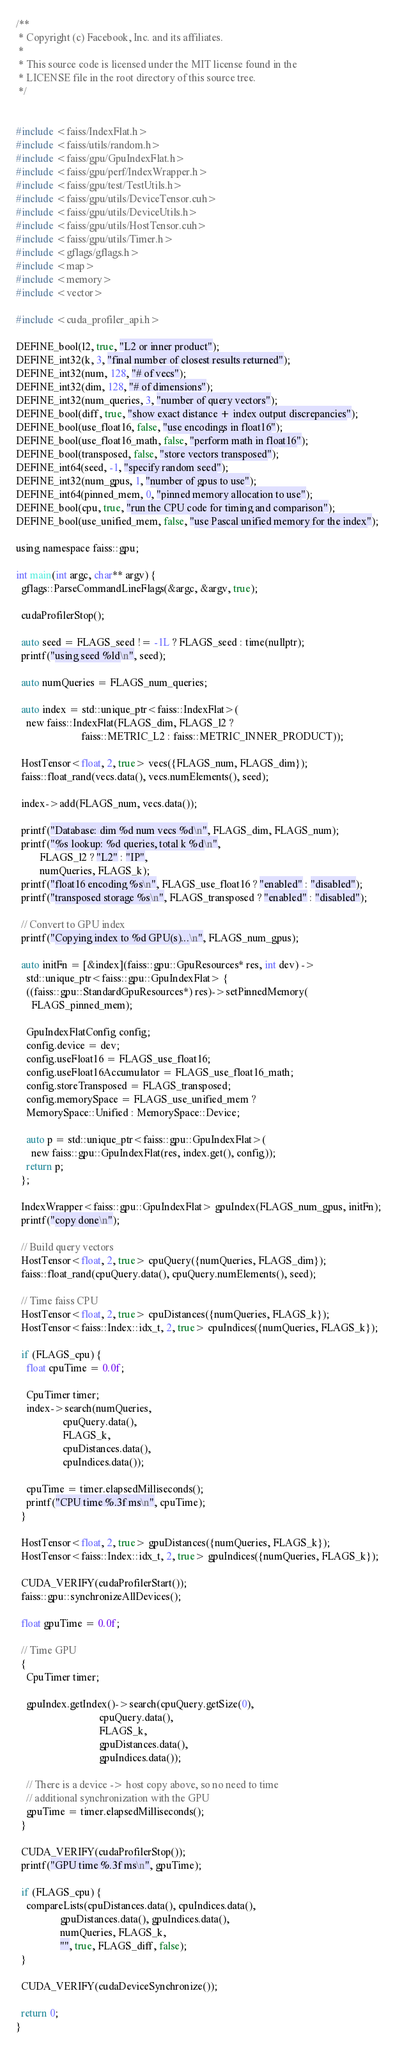Convert code to text. <code><loc_0><loc_0><loc_500><loc_500><_Cuda_>/**
 * Copyright (c) Facebook, Inc. and its affiliates.
 *
 * This source code is licensed under the MIT license found in the
 * LICENSE file in the root directory of this source tree.
 */


#include <faiss/IndexFlat.h>
#include <faiss/utils/random.h>
#include <faiss/gpu/GpuIndexFlat.h>
#include <faiss/gpu/perf/IndexWrapper.h>
#include <faiss/gpu/test/TestUtils.h>
#include <faiss/gpu/utils/DeviceTensor.cuh>
#include <faiss/gpu/utils/DeviceUtils.h>
#include <faiss/gpu/utils/HostTensor.cuh>
#include <faiss/gpu/utils/Timer.h>
#include <gflags/gflags.h>
#include <map>
#include <memory>
#include <vector>

#include <cuda_profiler_api.h>

DEFINE_bool(l2, true, "L2 or inner product");
DEFINE_int32(k, 3, "final number of closest results returned");
DEFINE_int32(num, 128, "# of vecs");
DEFINE_int32(dim, 128, "# of dimensions");
DEFINE_int32(num_queries, 3, "number of query vectors");
DEFINE_bool(diff, true, "show exact distance + index output discrepancies");
DEFINE_bool(use_float16, false, "use encodings in float16");
DEFINE_bool(use_float16_math, false, "perform math in float16");
DEFINE_bool(transposed, false, "store vectors transposed");
DEFINE_int64(seed, -1, "specify random seed");
DEFINE_int32(num_gpus, 1, "number of gpus to use");
DEFINE_int64(pinned_mem, 0, "pinned memory allocation to use");
DEFINE_bool(cpu, true, "run the CPU code for timing and comparison");
DEFINE_bool(use_unified_mem, false, "use Pascal unified memory for the index");

using namespace faiss::gpu;

int main(int argc, char** argv) {
  gflags::ParseCommandLineFlags(&argc, &argv, true);

  cudaProfilerStop();

  auto seed = FLAGS_seed != -1L ? FLAGS_seed : time(nullptr);
  printf("using seed %ld\n", seed);

  auto numQueries = FLAGS_num_queries;

  auto index = std::unique_ptr<faiss::IndexFlat>(
    new faiss::IndexFlat(FLAGS_dim, FLAGS_l2 ?
                         faiss::METRIC_L2 : faiss::METRIC_INNER_PRODUCT));

  HostTensor<float, 2, true> vecs({FLAGS_num, FLAGS_dim});
  faiss::float_rand(vecs.data(), vecs.numElements(), seed);

  index->add(FLAGS_num, vecs.data());

  printf("Database: dim %d num vecs %d\n", FLAGS_dim, FLAGS_num);
  printf("%s lookup: %d queries, total k %d\n",
         FLAGS_l2 ? "L2" : "IP",
         numQueries, FLAGS_k);
  printf("float16 encoding %s\n", FLAGS_use_float16 ? "enabled" : "disabled");
  printf("transposed storage %s\n", FLAGS_transposed ? "enabled" : "disabled");

  // Convert to GPU index
  printf("Copying index to %d GPU(s)...\n", FLAGS_num_gpus);

  auto initFn = [&index](faiss::gpu::GpuResources* res, int dev) ->
    std::unique_ptr<faiss::gpu::GpuIndexFlat> {
    ((faiss::gpu::StandardGpuResources*) res)->setPinnedMemory(
      FLAGS_pinned_mem);

    GpuIndexFlatConfig config;
    config.device = dev;
    config.useFloat16 = FLAGS_use_float16;
    config.useFloat16Accumulator = FLAGS_use_float16_math;
    config.storeTransposed = FLAGS_transposed;
    config.memorySpace = FLAGS_use_unified_mem ?
    MemorySpace::Unified : MemorySpace::Device;

    auto p = std::unique_ptr<faiss::gpu::GpuIndexFlat>(
      new faiss::gpu::GpuIndexFlat(res, index.get(), config));
    return p;
  };

  IndexWrapper<faiss::gpu::GpuIndexFlat> gpuIndex(FLAGS_num_gpus, initFn);
  printf("copy done\n");

  // Build query vectors
  HostTensor<float, 2, true> cpuQuery({numQueries, FLAGS_dim});
  faiss::float_rand(cpuQuery.data(), cpuQuery.numElements(), seed);

  // Time faiss CPU
  HostTensor<float, 2, true> cpuDistances({numQueries, FLAGS_k});
  HostTensor<faiss::Index::idx_t, 2, true> cpuIndices({numQueries, FLAGS_k});

  if (FLAGS_cpu) {
    float cpuTime = 0.0f;

    CpuTimer timer;
    index->search(numQueries,
                  cpuQuery.data(),
                  FLAGS_k,
                  cpuDistances.data(),
                  cpuIndices.data());

    cpuTime = timer.elapsedMilliseconds();
    printf("CPU time %.3f ms\n", cpuTime);
  }

  HostTensor<float, 2, true> gpuDistances({numQueries, FLAGS_k});
  HostTensor<faiss::Index::idx_t, 2, true> gpuIndices({numQueries, FLAGS_k});

  CUDA_VERIFY(cudaProfilerStart());
  faiss::gpu::synchronizeAllDevices();

  float gpuTime = 0.0f;

  // Time GPU
  {
    CpuTimer timer;

    gpuIndex.getIndex()->search(cpuQuery.getSize(0),
                                cpuQuery.data(),
                                FLAGS_k,
                                gpuDistances.data(),
                                gpuIndices.data());

    // There is a device -> host copy above, so no need to time
    // additional synchronization with the GPU
    gpuTime = timer.elapsedMilliseconds();
  }

  CUDA_VERIFY(cudaProfilerStop());
  printf("GPU time %.3f ms\n", gpuTime);

  if (FLAGS_cpu) {
    compareLists(cpuDistances.data(), cpuIndices.data(),
                 gpuDistances.data(), gpuIndices.data(),
                 numQueries, FLAGS_k,
                 "", true, FLAGS_diff, false);
  }

  CUDA_VERIFY(cudaDeviceSynchronize());

  return 0;
}
</code> 